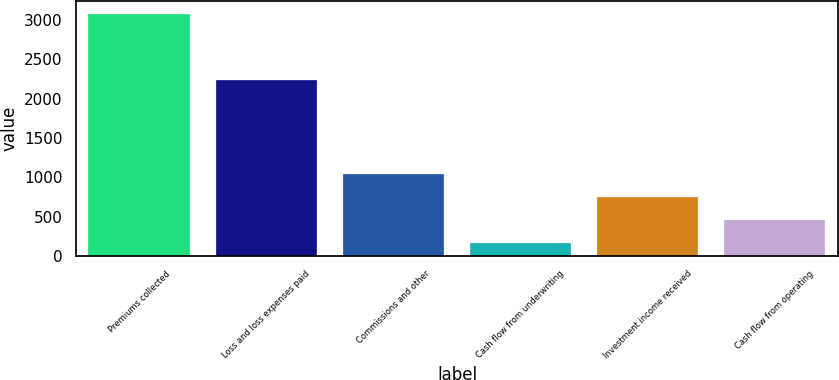<chart> <loc_0><loc_0><loc_500><loc_500><bar_chart><fcel>Premiums collected<fcel>Loss and loss expenses paid<fcel>Commissions and other<fcel>Cash flow from underwriting<fcel>Investment income received<fcel>Cash flow from operating<nl><fcel>3080<fcel>2241<fcel>1040.2<fcel>166<fcel>748.8<fcel>457.4<nl></chart> 